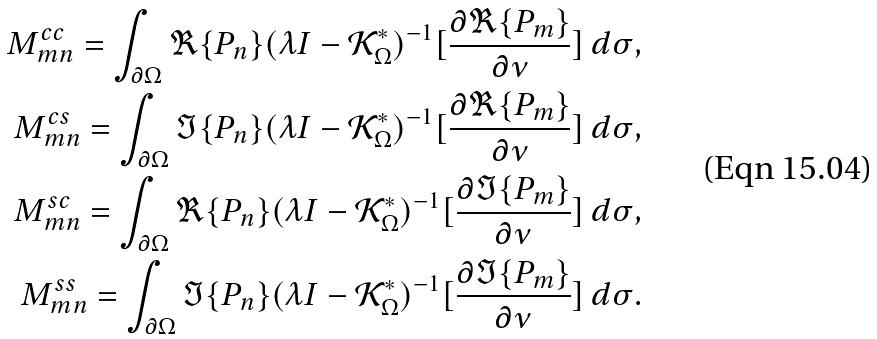Convert formula to latex. <formula><loc_0><loc_0><loc_500><loc_500>M ^ { c c } _ { m n } = \int _ { \partial \Omega } \Re \{ P _ { n } \} ( \lambda I - \mathcal { K } _ { \Omega } ^ { * } ) ^ { - 1 } [ \frac { \partial \Re \{ P _ { m } \} } { \partial \nu } ] \, d \sigma , \\ M ^ { c s } _ { m n } = \int _ { \partial \Omega } \Im \{ P _ { n } \} ( \lambda I - \mathcal { K } _ { \Omega } ^ { * } ) ^ { - 1 } [ \frac { \partial \Re \{ P _ { m } \} } { \partial \nu } ] \, d \sigma , \\ M ^ { s c } _ { m n } = \int _ { \partial \Omega } \Re \{ P _ { n } \} ( \lambda I - \mathcal { K } _ { \Omega } ^ { * } ) ^ { - 1 } [ \frac { \partial \Im \{ P _ { m } \} } { \partial \nu } ] \, d \sigma , \\ M ^ { s s } _ { m n } = \int _ { \partial \Omega } \Im \{ P _ { n } \} ( \lambda I - \mathcal { K } _ { \Omega } ^ { * } ) ^ { - 1 } [ \frac { \partial \Im \{ P _ { m } \} } { \partial \nu } ] \, d \sigma .</formula> 